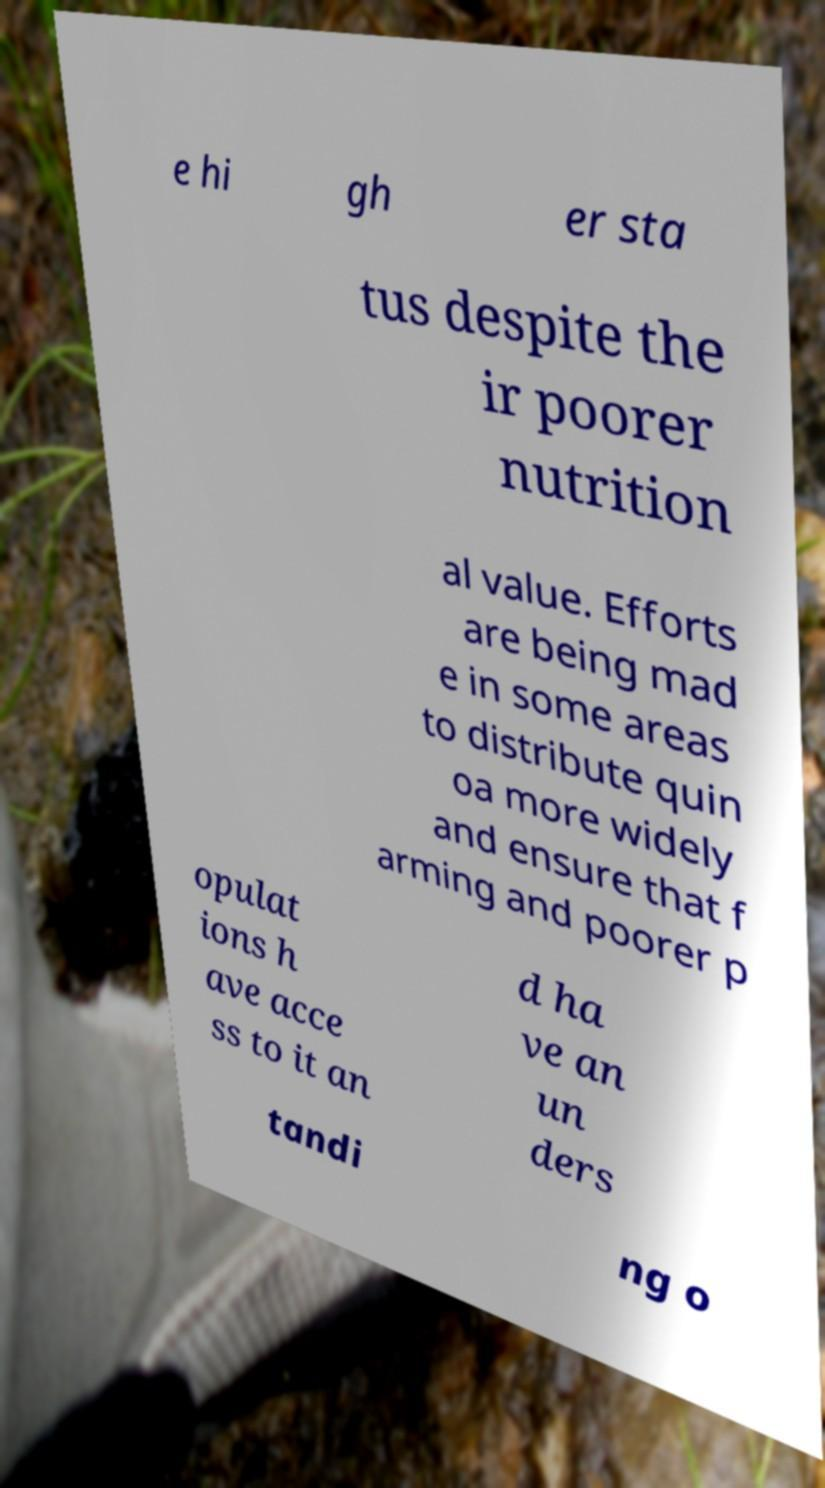For documentation purposes, I need the text within this image transcribed. Could you provide that? e hi gh er sta tus despite the ir poorer nutrition al value. Efforts are being mad e in some areas to distribute quin oa more widely and ensure that f arming and poorer p opulat ions h ave acce ss to it an d ha ve an un ders tandi ng o 